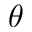<formula> <loc_0><loc_0><loc_500><loc_500>\theta</formula> 